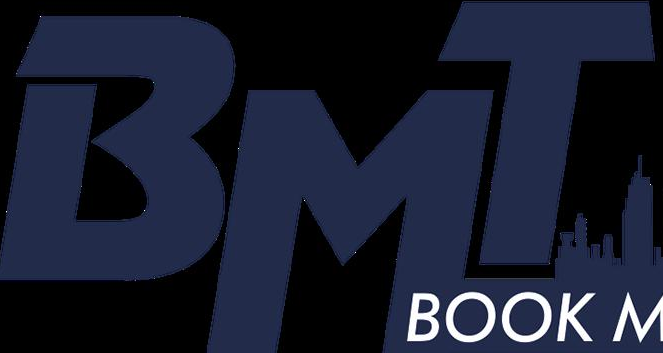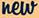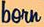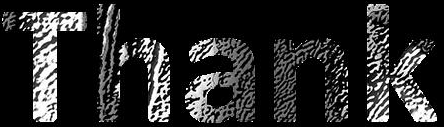What text is displayed in these images sequentially, separated by a semicolon? BMT; new; born; Thank 